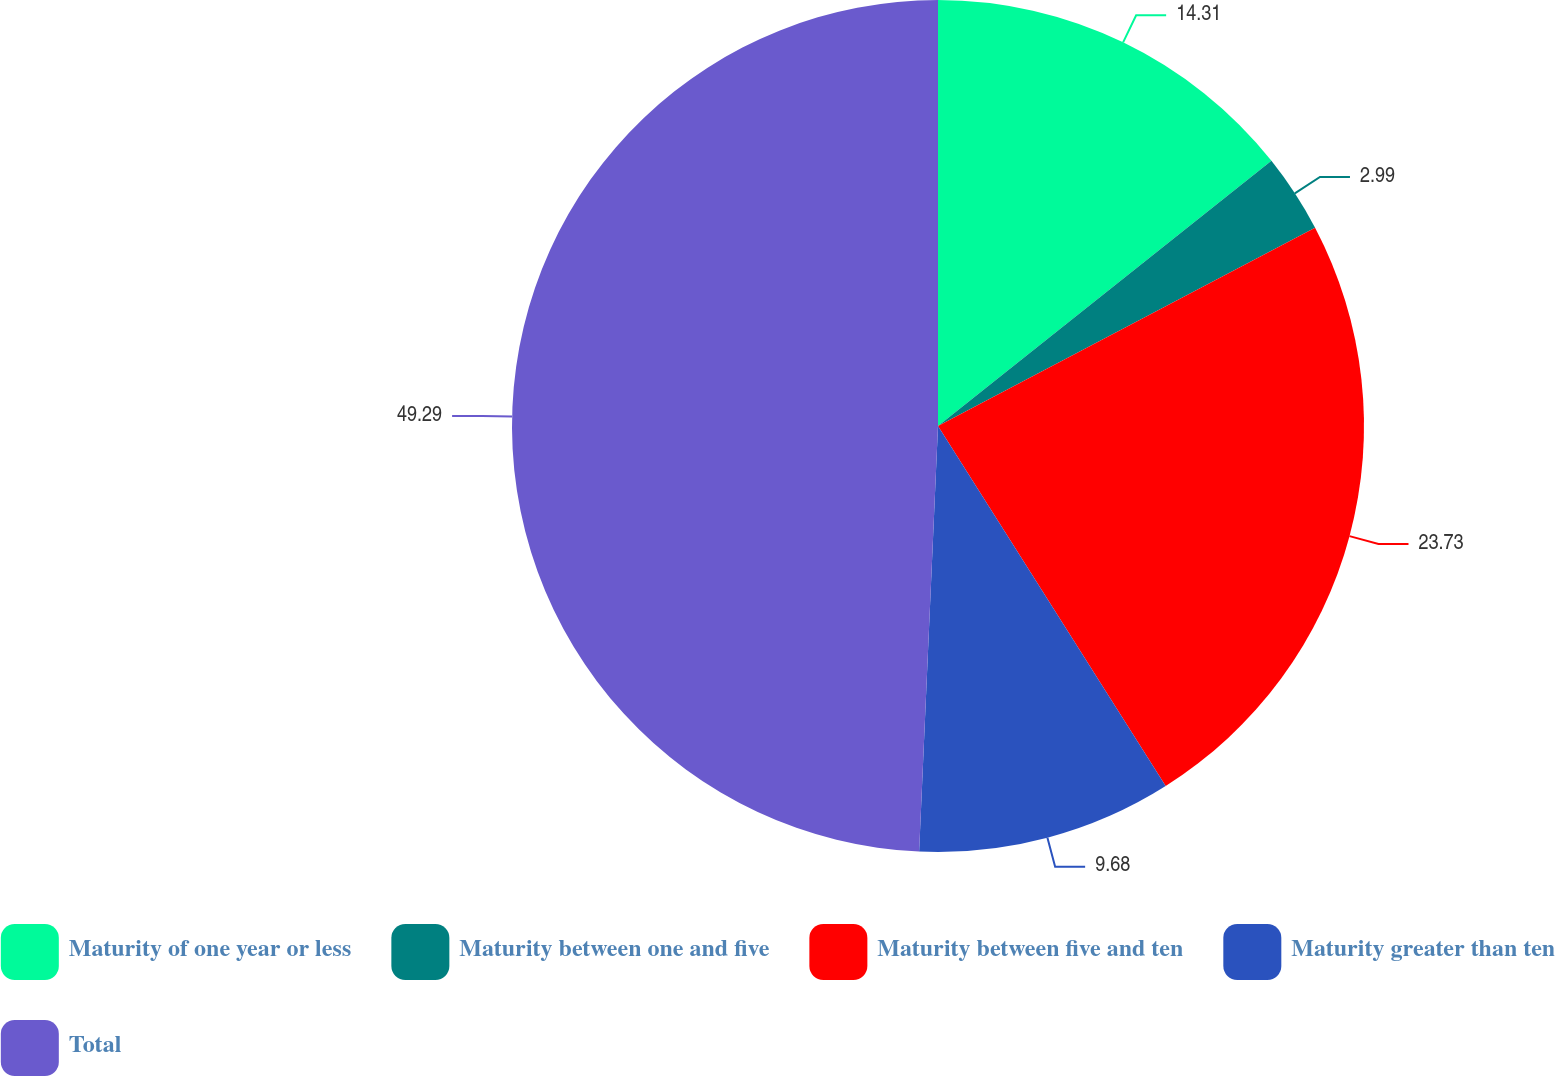Convert chart. <chart><loc_0><loc_0><loc_500><loc_500><pie_chart><fcel>Maturity of one year or less<fcel>Maturity between one and five<fcel>Maturity between five and ten<fcel>Maturity greater than ten<fcel>Total<nl><fcel>14.31%<fcel>2.99%<fcel>23.73%<fcel>9.68%<fcel>49.3%<nl></chart> 